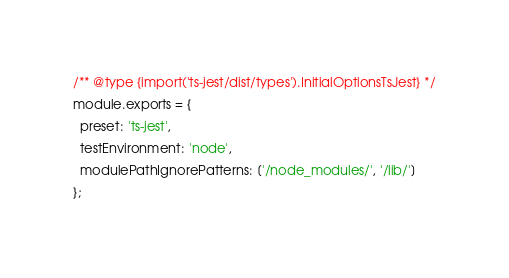<code> <loc_0><loc_0><loc_500><loc_500><_JavaScript_>/** @type {import('ts-jest/dist/types').InitialOptionsTsJest} */
module.exports = {
  preset: 'ts-jest',
  testEnvironment: 'node',
  modulePathIgnorePatterns: ['/node_modules/', '/lib/']
};</code> 